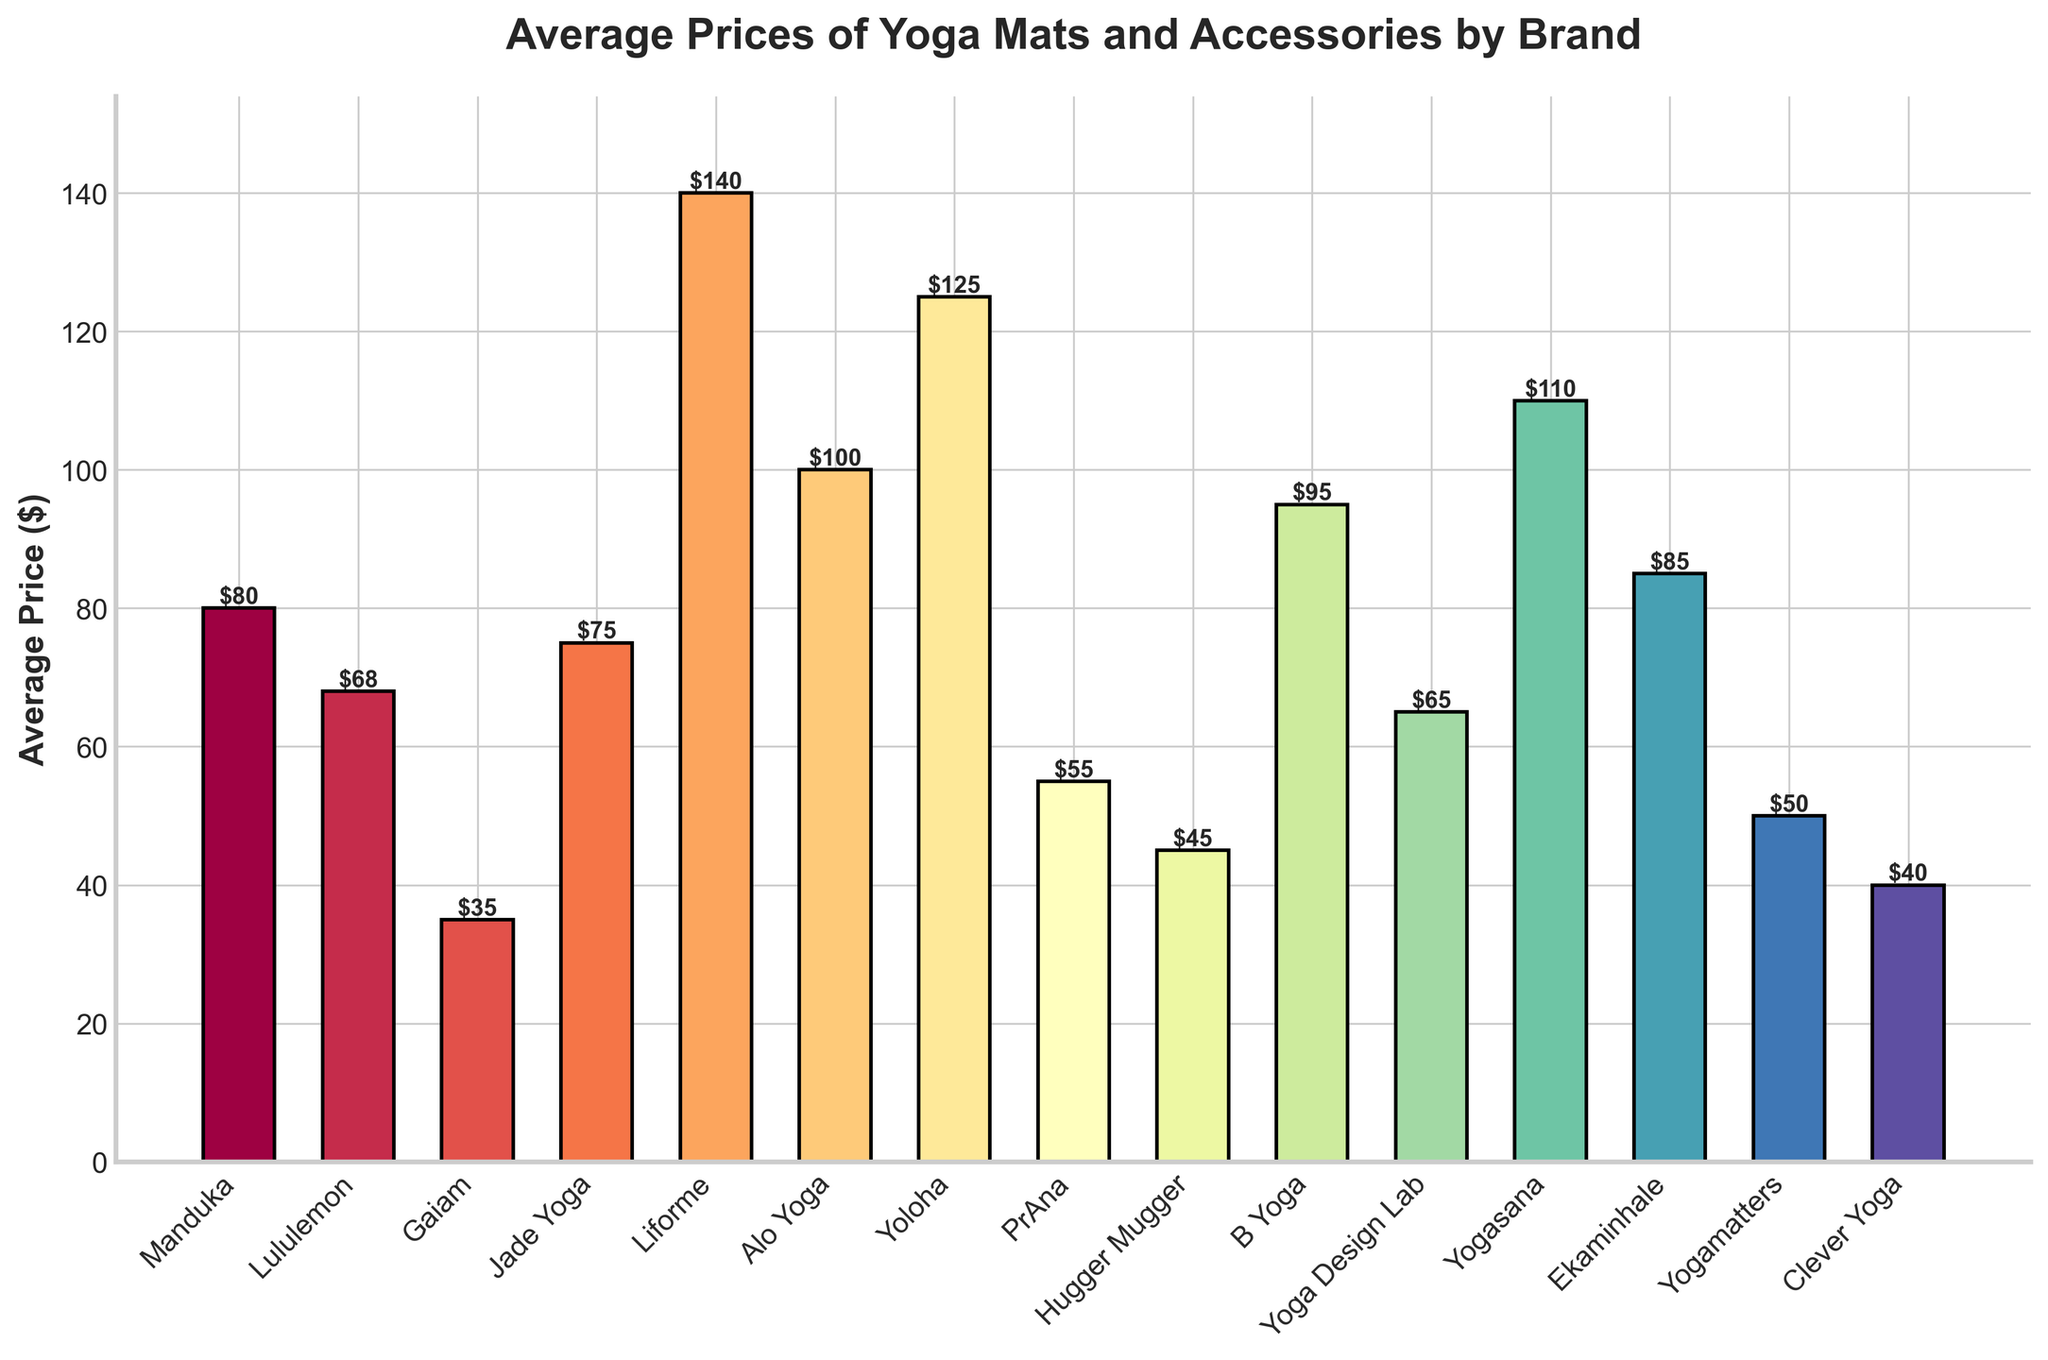What is the most expensive brand for yoga mats and accessories? To find the most expensive brand, look at the bar with the greatest height. The brand for this bar is Liforme, with an average price of $140.
Answer: Liforme Which brand has the lowest average price? The least expensive brand is identified by the shortest bar. Gaiam's bar is the shortest, with an average price of $35.
Answer: Gaiam Compare the average price of Yoloha and Yoga Design Lab. Which one is higher? Compare the heights of the bars representing Yoloha and Yoga Design Lab. Yoloha has an average price of $125, which is higher than Yoga Design Lab's average price of $65.
Answer: Yoloha What is the difference in average price between Clever Yoga and Hugger Mugger? Clever Yoga's average price is $40 and Hugger Mugger's is $45. The difference is calculated as $45 - $40 = $5.
Answer: $5 Calculate the average price of all brands combined. Add all the average prices together and divide by the number of brands. The total sum of the prices is $80 + $68 + $35 + $75 + $140 + $100 + $125 + $55 + $45 + $95 + $65 + $110 + $85 + $50 + $40 = $1168. There are 15 brands, so the average price is $1168 / 15 ≈ $77.87.
Answer: $77.87 What is the price range of the yoga mats and accessories? The price range is found by subtracting the smallest price from the largest price. The smallest price is $35 (Gaiam) and the largest is $140 (Liforme), so $140 - $35 = $105.
Answer: $105 Which brands have an average price greater than $100? Identify all the bars with heights corresponding to values greater than $100. The brands are Liforme ($140), Yoloha ($125), Alo Yoga ($100), Yogasana ($110).
Answer: Liforme, Yoloha, Yogasana Compare the average price of Manduka and Jade Yoga. Are they equal, and if not, which one is higher? Compare the heights of Manduka's and Jade Yoga's bars. Manduka’s average price is $80, and Jade Yoga’s is $75. Manduka is higher than Jade Yoga.
Answer: Manduka What is the sum of average prices for Lululemon, Alo Yoga, and Ekaminhale? Add the average prices of these three brands: $68 (Lululemon) + $100 (Alo Yoga) + $85 (Ekaminhale) = $253.
Answer: $253 